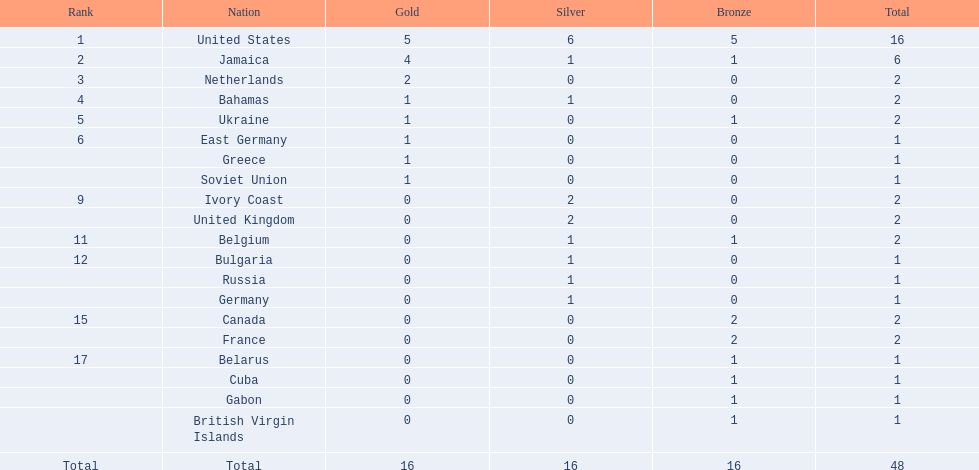Which nation secured the most medals? United States. How many medals did the us achieve? 16. What is the highest number of medals (after 16) earned by a nation? 6. Which nation obtained 6 medals? Jamaica. 